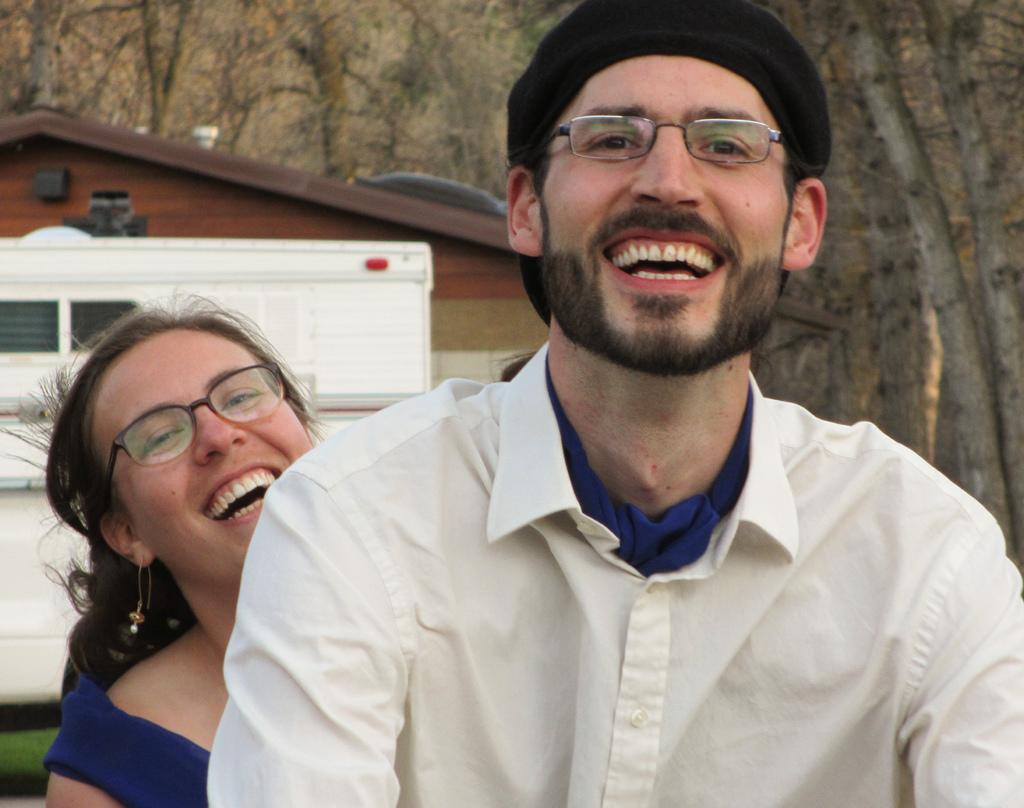Who are the people in the image? There is a man and a woman in the image. What are the man and woman doing in the image? The man and woman are both laughing. What is the man wearing in the image? The man is wearing a white color shirt. What is the woman wearing in the image? The woman is wearing a blue color dress. What can be seen in the background of the image? There is a wooden house and trees in the background of the image. Where are the scissors located in the image? There are no scissors present in the image. What causes the burst of laughter from the man and woman in the image? The image does not provide information about the cause of their laughter. 